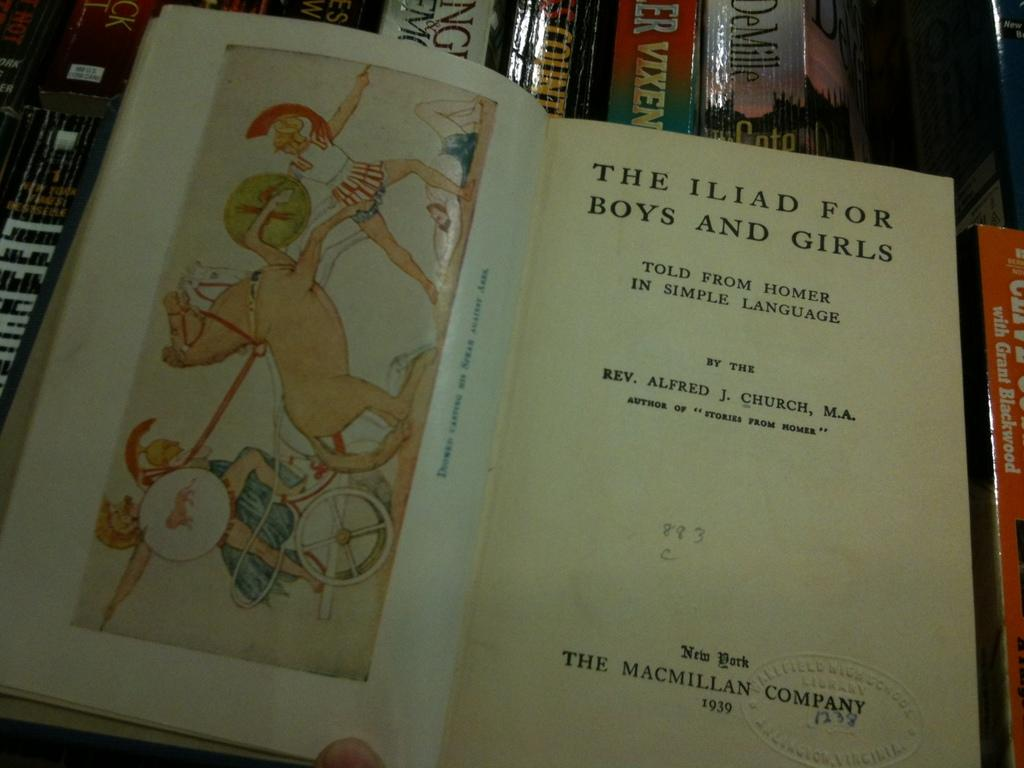Provide a one-sentence caption for the provided image. The title of the open book is The Iliad For Boys and Girls. 